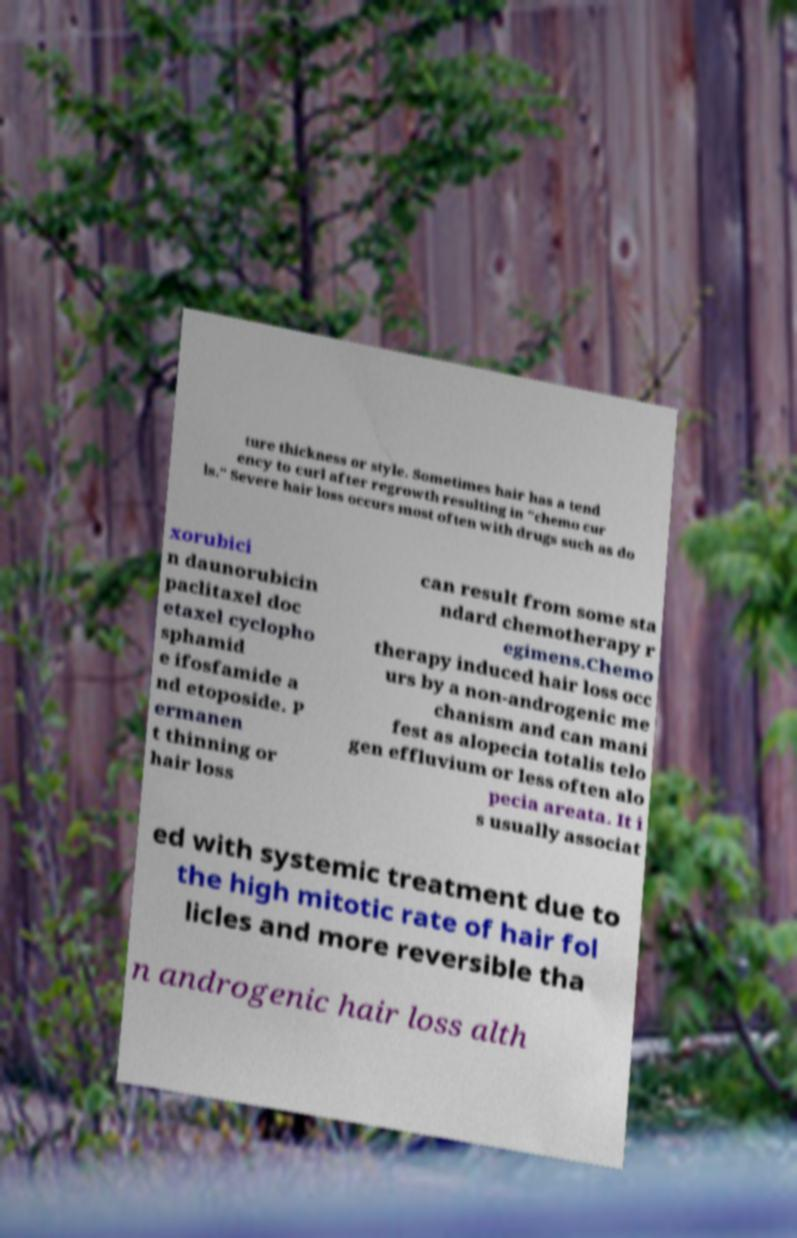Can you read and provide the text displayed in the image?This photo seems to have some interesting text. Can you extract and type it out for me? ture thickness or style. Sometimes hair has a tend ency to curl after regrowth resulting in "chemo cur ls." Severe hair loss occurs most often with drugs such as do xorubici n daunorubicin paclitaxel doc etaxel cyclopho sphamid e ifosfamide a nd etoposide. P ermanen t thinning or hair loss can result from some sta ndard chemotherapy r egimens.Chemo therapy induced hair loss occ urs by a non-androgenic me chanism and can mani fest as alopecia totalis telo gen effluvium or less often alo pecia areata. It i s usually associat ed with systemic treatment due to the high mitotic rate of hair fol licles and more reversible tha n androgenic hair loss alth 